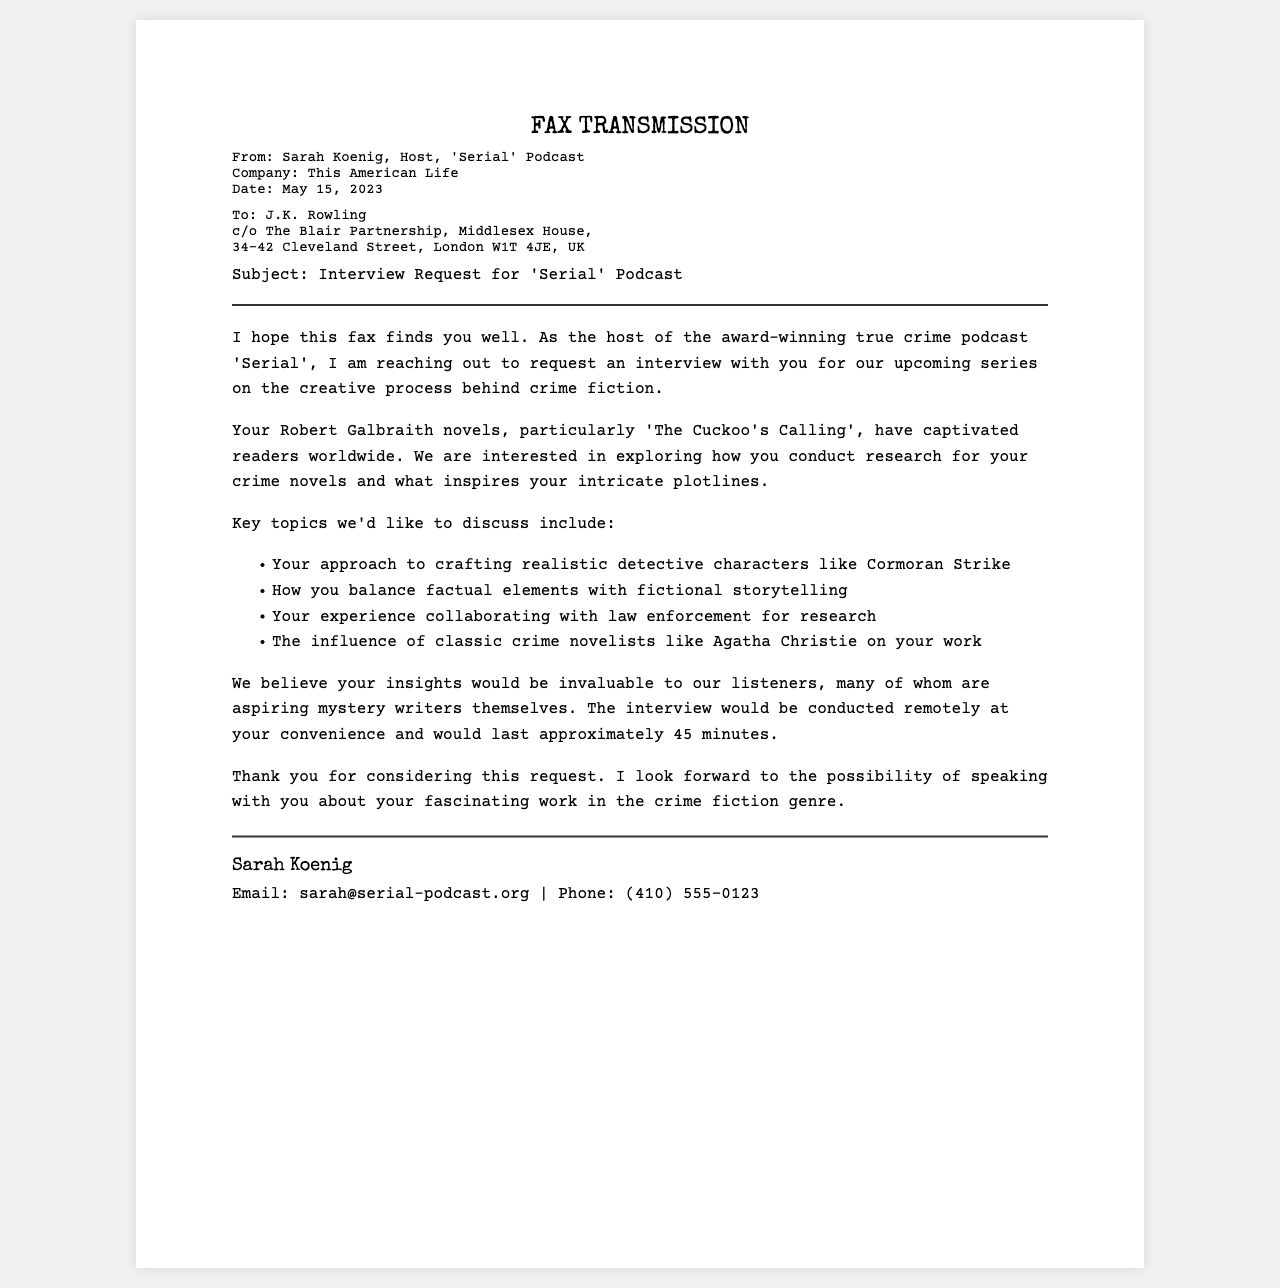what is the date of the fax? The date is provided in the sender's information section of the fax.
Answer: May 15, 2023 who is the sender of the fax? The sender's name is mentioned at the beginning of the fax in the sender's information.
Answer: Sarah Koenig what is the podcast mentioned in the fax? The name of the podcast is specified in the title of the fax.
Answer: Serial how long is the proposed interview duration? The interview duration is stated in the content section of the fax.
Answer: 45 minutes who is the recipient of the fax? The recipient's name and address are given in the recipient information section.
Answer: J.K. Rowling what is one key topic the podcast wants to discuss? Several key topics are listed in bullet points, selecting one example.
Answer: Realistic detective characters where is the recipient located? The recipient's address is outlined in the recipient information section.
Answer: London W1T 4JE, UK what is the email address of the sender? The sender's email is found in the fax footer.
Answer: sarah@serial-podcast.org what type of creative work is the focus of the interview? The focus is mentioned in the podcast's aim and the novels referenced in the fax.
Answer: Crime fiction 